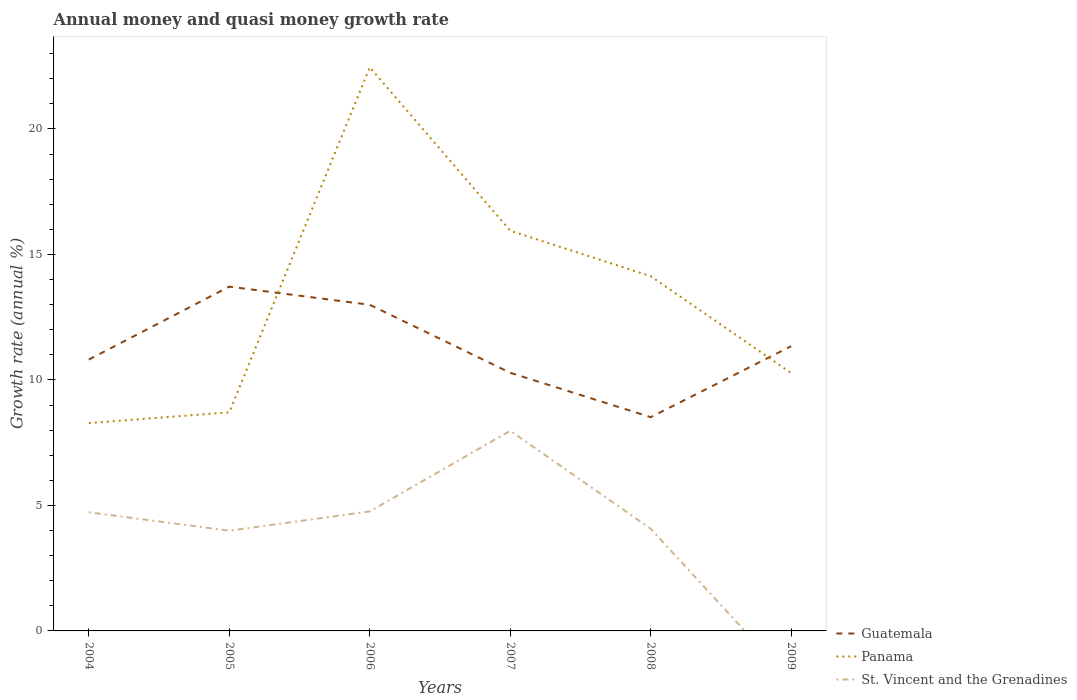How many different coloured lines are there?
Your response must be concise. 3. Across all years, what is the maximum growth rate in Panama?
Provide a short and direct response. 8.28. What is the total growth rate in Guatemala in the graph?
Give a very brief answer. -1.06. What is the difference between the highest and the second highest growth rate in Panama?
Give a very brief answer. 14.18. What is the difference between the highest and the lowest growth rate in Panama?
Offer a very short reply. 3. How many years are there in the graph?
Give a very brief answer. 6. What is the difference between two consecutive major ticks on the Y-axis?
Make the answer very short. 5. Does the graph contain any zero values?
Your answer should be very brief. Yes. Where does the legend appear in the graph?
Your response must be concise. Bottom right. How are the legend labels stacked?
Keep it short and to the point. Vertical. What is the title of the graph?
Provide a short and direct response. Annual money and quasi money growth rate. Does "Argentina" appear as one of the legend labels in the graph?
Make the answer very short. No. What is the label or title of the X-axis?
Your answer should be very brief. Years. What is the label or title of the Y-axis?
Your answer should be compact. Growth rate (annual %). What is the Growth rate (annual %) in Guatemala in 2004?
Offer a terse response. 10.81. What is the Growth rate (annual %) in Panama in 2004?
Offer a terse response. 8.28. What is the Growth rate (annual %) in St. Vincent and the Grenadines in 2004?
Provide a succinct answer. 4.73. What is the Growth rate (annual %) in Guatemala in 2005?
Give a very brief answer. 13.72. What is the Growth rate (annual %) in Panama in 2005?
Keep it short and to the point. 8.71. What is the Growth rate (annual %) in St. Vincent and the Grenadines in 2005?
Keep it short and to the point. 3.99. What is the Growth rate (annual %) in Guatemala in 2006?
Offer a terse response. 12.99. What is the Growth rate (annual %) in Panama in 2006?
Keep it short and to the point. 22.46. What is the Growth rate (annual %) of St. Vincent and the Grenadines in 2006?
Make the answer very short. 4.76. What is the Growth rate (annual %) of Guatemala in 2007?
Your answer should be compact. 10.29. What is the Growth rate (annual %) in Panama in 2007?
Make the answer very short. 15.95. What is the Growth rate (annual %) of St. Vincent and the Grenadines in 2007?
Provide a short and direct response. 7.98. What is the Growth rate (annual %) of Guatemala in 2008?
Your answer should be very brief. 8.52. What is the Growth rate (annual %) of Panama in 2008?
Your response must be concise. 14.13. What is the Growth rate (annual %) in St. Vincent and the Grenadines in 2008?
Your answer should be very brief. 4.07. What is the Growth rate (annual %) of Guatemala in 2009?
Keep it short and to the point. 11.35. What is the Growth rate (annual %) in Panama in 2009?
Give a very brief answer. 10.27. What is the Growth rate (annual %) in St. Vincent and the Grenadines in 2009?
Your answer should be very brief. 0. Across all years, what is the maximum Growth rate (annual %) of Guatemala?
Keep it short and to the point. 13.72. Across all years, what is the maximum Growth rate (annual %) in Panama?
Your response must be concise. 22.46. Across all years, what is the maximum Growth rate (annual %) in St. Vincent and the Grenadines?
Provide a succinct answer. 7.98. Across all years, what is the minimum Growth rate (annual %) of Guatemala?
Make the answer very short. 8.52. Across all years, what is the minimum Growth rate (annual %) in Panama?
Give a very brief answer. 8.28. Across all years, what is the minimum Growth rate (annual %) of St. Vincent and the Grenadines?
Your answer should be very brief. 0. What is the total Growth rate (annual %) in Guatemala in the graph?
Provide a short and direct response. 67.67. What is the total Growth rate (annual %) in Panama in the graph?
Make the answer very short. 79.8. What is the total Growth rate (annual %) in St. Vincent and the Grenadines in the graph?
Offer a terse response. 25.53. What is the difference between the Growth rate (annual %) of Guatemala in 2004 and that in 2005?
Make the answer very short. -2.91. What is the difference between the Growth rate (annual %) in Panama in 2004 and that in 2005?
Provide a succinct answer. -0.43. What is the difference between the Growth rate (annual %) of St. Vincent and the Grenadines in 2004 and that in 2005?
Your response must be concise. 0.73. What is the difference between the Growth rate (annual %) in Guatemala in 2004 and that in 2006?
Offer a very short reply. -2.18. What is the difference between the Growth rate (annual %) in Panama in 2004 and that in 2006?
Offer a terse response. -14.18. What is the difference between the Growth rate (annual %) of St. Vincent and the Grenadines in 2004 and that in 2006?
Your answer should be compact. -0.03. What is the difference between the Growth rate (annual %) in Guatemala in 2004 and that in 2007?
Make the answer very short. 0.52. What is the difference between the Growth rate (annual %) in Panama in 2004 and that in 2007?
Offer a terse response. -7.66. What is the difference between the Growth rate (annual %) of St. Vincent and the Grenadines in 2004 and that in 2007?
Ensure brevity in your answer.  -3.25. What is the difference between the Growth rate (annual %) of Guatemala in 2004 and that in 2008?
Ensure brevity in your answer.  2.29. What is the difference between the Growth rate (annual %) in Panama in 2004 and that in 2008?
Offer a very short reply. -5.85. What is the difference between the Growth rate (annual %) of St. Vincent and the Grenadines in 2004 and that in 2008?
Offer a very short reply. 0.66. What is the difference between the Growth rate (annual %) in Guatemala in 2004 and that in 2009?
Ensure brevity in your answer.  -0.54. What is the difference between the Growth rate (annual %) of Panama in 2004 and that in 2009?
Keep it short and to the point. -1.99. What is the difference between the Growth rate (annual %) of Guatemala in 2005 and that in 2006?
Your answer should be compact. 0.73. What is the difference between the Growth rate (annual %) in Panama in 2005 and that in 2006?
Your answer should be compact. -13.75. What is the difference between the Growth rate (annual %) of St. Vincent and the Grenadines in 2005 and that in 2006?
Your answer should be compact. -0.77. What is the difference between the Growth rate (annual %) of Guatemala in 2005 and that in 2007?
Make the answer very short. 3.43. What is the difference between the Growth rate (annual %) of Panama in 2005 and that in 2007?
Your answer should be very brief. -7.24. What is the difference between the Growth rate (annual %) in St. Vincent and the Grenadines in 2005 and that in 2007?
Offer a very short reply. -3.98. What is the difference between the Growth rate (annual %) of Guatemala in 2005 and that in 2008?
Provide a short and direct response. 5.2. What is the difference between the Growth rate (annual %) in Panama in 2005 and that in 2008?
Provide a succinct answer. -5.42. What is the difference between the Growth rate (annual %) in St. Vincent and the Grenadines in 2005 and that in 2008?
Your answer should be very brief. -0.08. What is the difference between the Growth rate (annual %) of Guatemala in 2005 and that in 2009?
Offer a terse response. 2.37. What is the difference between the Growth rate (annual %) of Panama in 2005 and that in 2009?
Offer a terse response. -1.56. What is the difference between the Growth rate (annual %) in Guatemala in 2006 and that in 2007?
Your answer should be very brief. 2.71. What is the difference between the Growth rate (annual %) of Panama in 2006 and that in 2007?
Offer a very short reply. 6.51. What is the difference between the Growth rate (annual %) in St. Vincent and the Grenadines in 2006 and that in 2007?
Your answer should be very brief. -3.21. What is the difference between the Growth rate (annual %) of Guatemala in 2006 and that in 2008?
Ensure brevity in your answer.  4.48. What is the difference between the Growth rate (annual %) in Panama in 2006 and that in 2008?
Offer a terse response. 8.32. What is the difference between the Growth rate (annual %) in St. Vincent and the Grenadines in 2006 and that in 2008?
Give a very brief answer. 0.69. What is the difference between the Growth rate (annual %) of Guatemala in 2006 and that in 2009?
Provide a succinct answer. 1.65. What is the difference between the Growth rate (annual %) of Panama in 2006 and that in 2009?
Offer a very short reply. 12.19. What is the difference between the Growth rate (annual %) in Guatemala in 2007 and that in 2008?
Provide a short and direct response. 1.77. What is the difference between the Growth rate (annual %) of Panama in 2007 and that in 2008?
Offer a terse response. 1.81. What is the difference between the Growth rate (annual %) in St. Vincent and the Grenadines in 2007 and that in 2008?
Your answer should be very brief. 3.9. What is the difference between the Growth rate (annual %) in Guatemala in 2007 and that in 2009?
Offer a terse response. -1.06. What is the difference between the Growth rate (annual %) of Panama in 2007 and that in 2009?
Keep it short and to the point. 5.67. What is the difference between the Growth rate (annual %) in Guatemala in 2008 and that in 2009?
Ensure brevity in your answer.  -2.83. What is the difference between the Growth rate (annual %) of Panama in 2008 and that in 2009?
Offer a very short reply. 3.86. What is the difference between the Growth rate (annual %) of Guatemala in 2004 and the Growth rate (annual %) of Panama in 2005?
Your answer should be compact. 2.1. What is the difference between the Growth rate (annual %) in Guatemala in 2004 and the Growth rate (annual %) in St. Vincent and the Grenadines in 2005?
Provide a succinct answer. 6.82. What is the difference between the Growth rate (annual %) of Panama in 2004 and the Growth rate (annual %) of St. Vincent and the Grenadines in 2005?
Provide a succinct answer. 4.29. What is the difference between the Growth rate (annual %) in Guatemala in 2004 and the Growth rate (annual %) in Panama in 2006?
Your response must be concise. -11.65. What is the difference between the Growth rate (annual %) of Guatemala in 2004 and the Growth rate (annual %) of St. Vincent and the Grenadines in 2006?
Provide a short and direct response. 6.05. What is the difference between the Growth rate (annual %) of Panama in 2004 and the Growth rate (annual %) of St. Vincent and the Grenadines in 2006?
Keep it short and to the point. 3.52. What is the difference between the Growth rate (annual %) in Guatemala in 2004 and the Growth rate (annual %) in Panama in 2007?
Make the answer very short. -5.13. What is the difference between the Growth rate (annual %) in Guatemala in 2004 and the Growth rate (annual %) in St. Vincent and the Grenadines in 2007?
Your response must be concise. 2.83. What is the difference between the Growth rate (annual %) of Panama in 2004 and the Growth rate (annual %) of St. Vincent and the Grenadines in 2007?
Keep it short and to the point. 0.31. What is the difference between the Growth rate (annual %) in Guatemala in 2004 and the Growth rate (annual %) in Panama in 2008?
Provide a succinct answer. -3.32. What is the difference between the Growth rate (annual %) in Guatemala in 2004 and the Growth rate (annual %) in St. Vincent and the Grenadines in 2008?
Make the answer very short. 6.74. What is the difference between the Growth rate (annual %) in Panama in 2004 and the Growth rate (annual %) in St. Vincent and the Grenadines in 2008?
Offer a very short reply. 4.21. What is the difference between the Growth rate (annual %) in Guatemala in 2004 and the Growth rate (annual %) in Panama in 2009?
Give a very brief answer. 0.54. What is the difference between the Growth rate (annual %) of Guatemala in 2005 and the Growth rate (annual %) of Panama in 2006?
Your answer should be compact. -8.74. What is the difference between the Growth rate (annual %) of Guatemala in 2005 and the Growth rate (annual %) of St. Vincent and the Grenadines in 2006?
Your answer should be compact. 8.96. What is the difference between the Growth rate (annual %) in Panama in 2005 and the Growth rate (annual %) in St. Vincent and the Grenadines in 2006?
Offer a terse response. 3.95. What is the difference between the Growth rate (annual %) in Guatemala in 2005 and the Growth rate (annual %) in Panama in 2007?
Offer a very short reply. -2.23. What is the difference between the Growth rate (annual %) of Guatemala in 2005 and the Growth rate (annual %) of St. Vincent and the Grenadines in 2007?
Provide a succinct answer. 5.74. What is the difference between the Growth rate (annual %) in Panama in 2005 and the Growth rate (annual %) in St. Vincent and the Grenadines in 2007?
Keep it short and to the point. 0.73. What is the difference between the Growth rate (annual %) in Guatemala in 2005 and the Growth rate (annual %) in Panama in 2008?
Ensure brevity in your answer.  -0.41. What is the difference between the Growth rate (annual %) of Guatemala in 2005 and the Growth rate (annual %) of St. Vincent and the Grenadines in 2008?
Ensure brevity in your answer.  9.65. What is the difference between the Growth rate (annual %) of Panama in 2005 and the Growth rate (annual %) of St. Vincent and the Grenadines in 2008?
Offer a very short reply. 4.64. What is the difference between the Growth rate (annual %) in Guatemala in 2005 and the Growth rate (annual %) in Panama in 2009?
Give a very brief answer. 3.45. What is the difference between the Growth rate (annual %) of Guatemala in 2006 and the Growth rate (annual %) of Panama in 2007?
Provide a short and direct response. -2.95. What is the difference between the Growth rate (annual %) in Guatemala in 2006 and the Growth rate (annual %) in St. Vincent and the Grenadines in 2007?
Give a very brief answer. 5.02. What is the difference between the Growth rate (annual %) in Panama in 2006 and the Growth rate (annual %) in St. Vincent and the Grenadines in 2007?
Your answer should be compact. 14.48. What is the difference between the Growth rate (annual %) of Guatemala in 2006 and the Growth rate (annual %) of Panama in 2008?
Make the answer very short. -1.14. What is the difference between the Growth rate (annual %) in Guatemala in 2006 and the Growth rate (annual %) in St. Vincent and the Grenadines in 2008?
Your answer should be very brief. 8.92. What is the difference between the Growth rate (annual %) of Panama in 2006 and the Growth rate (annual %) of St. Vincent and the Grenadines in 2008?
Your response must be concise. 18.39. What is the difference between the Growth rate (annual %) of Guatemala in 2006 and the Growth rate (annual %) of Panama in 2009?
Your answer should be compact. 2.72. What is the difference between the Growth rate (annual %) of Guatemala in 2007 and the Growth rate (annual %) of Panama in 2008?
Keep it short and to the point. -3.85. What is the difference between the Growth rate (annual %) in Guatemala in 2007 and the Growth rate (annual %) in St. Vincent and the Grenadines in 2008?
Your answer should be very brief. 6.21. What is the difference between the Growth rate (annual %) of Panama in 2007 and the Growth rate (annual %) of St. Vincent and the Grenadines in 2008?
Give a very brief answer. 11.87. What is the difference between the Growth rate (annual %) of Guatemala in 2007 and the Growth rate (annual %) of Panama in 2009?
Offer a very short reply. 0.01. What is the difference between the Growth rate (annual %) in Guatemala in 2008 and the Growth rate (annual %) in Panama in 2009?
Give a very brief answer. -1.76. What is the average Growth rate (annual %) in Guatemala per year?
Provide a short and direct response. 11.28. What is the average Growth rate (annual %) of Panama per year?
Give a very brief answer. 13.3. What is the average Growth rate (annual %) of St. Vincent and the Grenadines per year?
Ensure brevity in your answer.  4.25. In the year 2004, what is the difference between the Growth rate (annual %) in Guatemala and Growth rate (annual %) in Panama?
Offer a terse response. 2.53. In the year 2004, what is the difference between the Growth rate (annual %) of Guatemala and Growth rate (annual %) of St. Vincent and the Grenadines?
Ensure brevity in your answer.  6.08. In the year 2004, what is the difference between the Growth rate (annual %) in Panama and Growth rate (annual %) in St. Vincent and the Grenadines?
Your response must be concise. 3.55. In the year 2005, what is the difference between the Growth rate (annual %) of Guatemala and Growth rate (annual %) of Panama?
Your answer should be very brief. 5.01. In the year 2005, what is the difference between the Growth rate (annual %) in Guatemala and Growth rate (annual %) in St. Vincent and the Grenadines?
Your answer should be very brief. 9.73. In the year 2005, what is the difference between the Growth rate (annual %) in Panama and Growth rate (annual %) in St. Vincent and the Grenadines?
Ensure brevity in your answer.  4.72. In the year 2006, what is the difference between the Growth rate (annual %) in Guatemala and Growth rate (annual %) in Panama?
Provide a short and direct response. -9.46. In the year 2006, what is the difference between the Growth rate (annual %) of Guatemala and Growth rate (annual %) of St. Vincent and the Grenadines?
Your answer should be very brief. 8.23. In the year 2006, what is the difference between the Growth rate (annual %) of Panama and Growth rate (annual %) of St. Vincent and the Grenadines?
Ensure brevity in your answer.  17.7. In the year 2007, what is the difference between the Growth rate (annual %) of Guatemala and Growth rate (annual %) of Panama?
Your answer should be compact. -5.66. In the year 2007, what is the difference between the Growth rate (annual %) of Guatemala and Growth rate (annual %) of St. Vincent and the Grenadines?
Make the answer very short. 2.31. In the year 2007, what is the difference between the Growth rate (annual %) of Panama and Growth rate (annual %) of St. Vincent and the Grenadines?
Offer a terse response. 7.97. In the year 2008, what is the difference between the Growth rate (annual %) in Guatemala and Growth rate (annual %) in Panama?
Your answer should be compact. -5.62. In the year 2008, what is the difference between the Growth rate (annual %) of Guatemala and Growth rate (annual %) of St. Vincent and the Grenadines?
Make the answer very short. 4.45. In the year 2008, what is the difference between the Growth rate (annual %) of Panama and Growth rate (annual %) of St. Vincent and the Grenadines?
Ensure brevity in your answer.  10.06. In the year 2009, what is the difference between the Growth rate (annual %) in Guatemala and Growth rate (annual %) in Panama?
Your answer should be compact. 1.07. What is the ratio of the Growth rate (annual %) of Guatemala in 2004 to that in 2005?
Provide a succinct answer. 0.79. What is the ratio of the Growth rate (annual %) in Panama in 2004 to that in 2005?
Ensure brevity in your answer.  0.95. What is the ratio of the Growth rate (annual %) of St. Vincent and the Grenadines in 2004 to that in 2005?
Your answer should be very brief. 1.18. What is the ratio of the Growth rate (annual %) of Guatemala in 2004 to that in 2006?
Offer a very short reply. 0.83. What is the ratio of the Growth rate (annual %) in Panama in 2004 to that in 2006?
Provide a succinct answer. 0.37. What is the ratio of the Growth rate (annual %) in St. Vincent and the Grenadines in 2004 to that in 2006?
Your answer should be compact. 0.99. What is the ratio of the Growth rate (annual %) of Guatemala in 2004 to that in 2007?
Make the answer very short. 1.05. What is the ratio of the Growth rate (annual %) of Panama in 2004 to that in 2007?
Keep it short and to the point. 0.52. What is the ratio of the Growth rate (annual %) of St. Vincent and the Grenadines in 2004 to that in 2007?
Offer a very short reply. 0.59. What is the ratio of the Growth rate (annual %) of Guatemala in 2004 to that in 2008?
Make the answer very short. 1.27. What is the ratio of the Growth rate (annual %) of Panama in 2004 to that in 2008?
Your response must be concise. 0.59. What is the ratio of the Growth rate (annual %) in St. Vincent and the Grenadines in 2004 to that in 2008?
Ensure brevity in your answer.  1.16. What is the ratio of the Growth rate (annual %) in Guatemala in 2004 to that in 2009?
Give a very brief answer. 0.95. What is the ratio of the Growth rate (annual %) in Panama in 2004 to that in 2009?
Keep it short and to the point. 0.81. What is the ratio of the Growth rate (annual %) in Guatemala in 2005 to that in 2006?
Your response must be concise. 1.06. What is the ratio of the Growth rate (annual %) of Panama in 2005 to that in 2006?
Offer a very short reply. 0.39. What is the ratio of the Growth rate (annual %) of St. Vincent and the Grenadines in 2005 to that in 2006?
Give a very brief answer. 0.84. What is the ratio of the Growth rate (annual %) of Guatemala in 2005 to that in 2007?
Provide a succinct answer. 1.33. What is the ratio of the Growth rate (annual %) of Panama in 2005 to that in 2007?
Your answer should be very brief. 0.55. What is the ratio of the Growth rate (annual %) of St. Vincent and the Grenadines in 2005 to that in 2007?
Make the answer very short. 0.5. What is the ratio of the Growth rate (annual %) in Guatemala in 2005 to that in 2008?
Offer a very short reply. 1.61. What is the ratio of the Growth rate (annual %) in Panama in 2005 to that in 2008?
Provide a short and direct response. 0.62. What is the ratio of the Growth rate (annual %) of St. Vincent and the Grenadines in 2005 to that in 2008?
Ensure brevity in your answer.  0.98. What is the ratio of the Growth rate (annual %) in Guatemala in 2005 to that in 2009?
Offer a terse response. 1.21. What is the ratio of the Growth rate (annual %) of Panama in 2005 to that in 2009?
Give a very brief answer. 0.85. What is the ratio of the Growth rate (annual %) of Guatemala in 2006 to that in 2007?
Make the answer very short. 1.26. What is the ratio of the Growth rate (annual %) in Panama in 2006 to that in 2007?
Provide a succinct answer. 1.41. What is the ratio of the Growth rate (annual %) in St. Vincent and the Grenadines in 2006 to that in 2007?
Make the answer very short. 0.6. What is the ratio of the Growth rate (annual %) in Guatemala in 2006 to that in 2008?
Your response must be concise. 1.53. What is the ratio of the Growth rate (annual %) in Panama in 2006 to that in 2008?
Keep it short and to the point. 1.59. What is the ratio of the Growth rate (annual %) of St. Vincent and the Grenadines in 2006 to that in 2008?
Your response must be concise. 1.17. What is the ratio of the Growth rate (annual %) in Guatemala in 2006 to that in 2009?
Make the answer very short. 1.15. What is the ratio of the Growth rate (annual %) in Panama in 2006 to that in 2009?
Provide a succinct answer. 2.19. What is the ratio of the Growth rate (annual %) in Guatemala in 2007 to that in 2008?
Provide a succinct answer. 1.21. What is the ratio of the Growth rate (annual %) in Panama in 2007 to that in 2008?
Make the answer very short. 1.13. What is the ratio of the Growth rate (annual %) in St. Vincent and the Grenadines in 2007 to that in 2008?
Provide a succinct answer. 1.96. What is the ratio of the Growth rate (annual %) of Guatemala in 2007 to that in 2009?
Your answer should be compact. 0.91. What is the ratio of the Growth rate (annual %) of Panama in 2007 to that in 2009?
Give a very brief answer. 1.55. What is the ratio of the Growth rate (annual %) of Guatemala in 2008 to that in 2009?
Offer a very short reply. 0.75. What is the ratio of the Growth rate (annual %) in Panama in 2008 to that in 2009?
Ensure brevity in your answer.  1.38. What is the difference between the highest and the second highest Growth rate (annual %) in Guatemala?
Ensure brevity in your answer.  0.73. What is the difference between the highest and the second highest Growth rate (annual %) of Panama?
Offer a very short reply. 6.51. What is the difference between the highest and the second highest Growth rate (annual %) of St. Vincent and the Grenadines?
Provide a short and direct response. 3.21. What is the difference between the highest and the lowest Growth rate (annual %) of Guatemala?
Keep it short and to the point. 5.2. What is the difference between the highest and the lowest Growth rate (annual %) of Panama?
Your answer should be very brief. 14.18. What is the difference between the highest and the lowest Growth rate (annual %) in St. Vincent and the Grenadines?
Offer a very short reply. 7.98. 